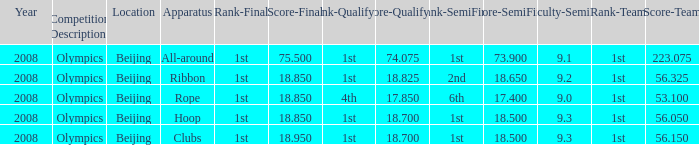What was her lowest final score with a qualifying score of 74.075? 75.5. 